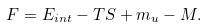Convert formula to latex. <formula><loc_0><loc_0><loc_500><loc_500>F = E _ { i n t } - T S + m _ { u } - M .</formula> 